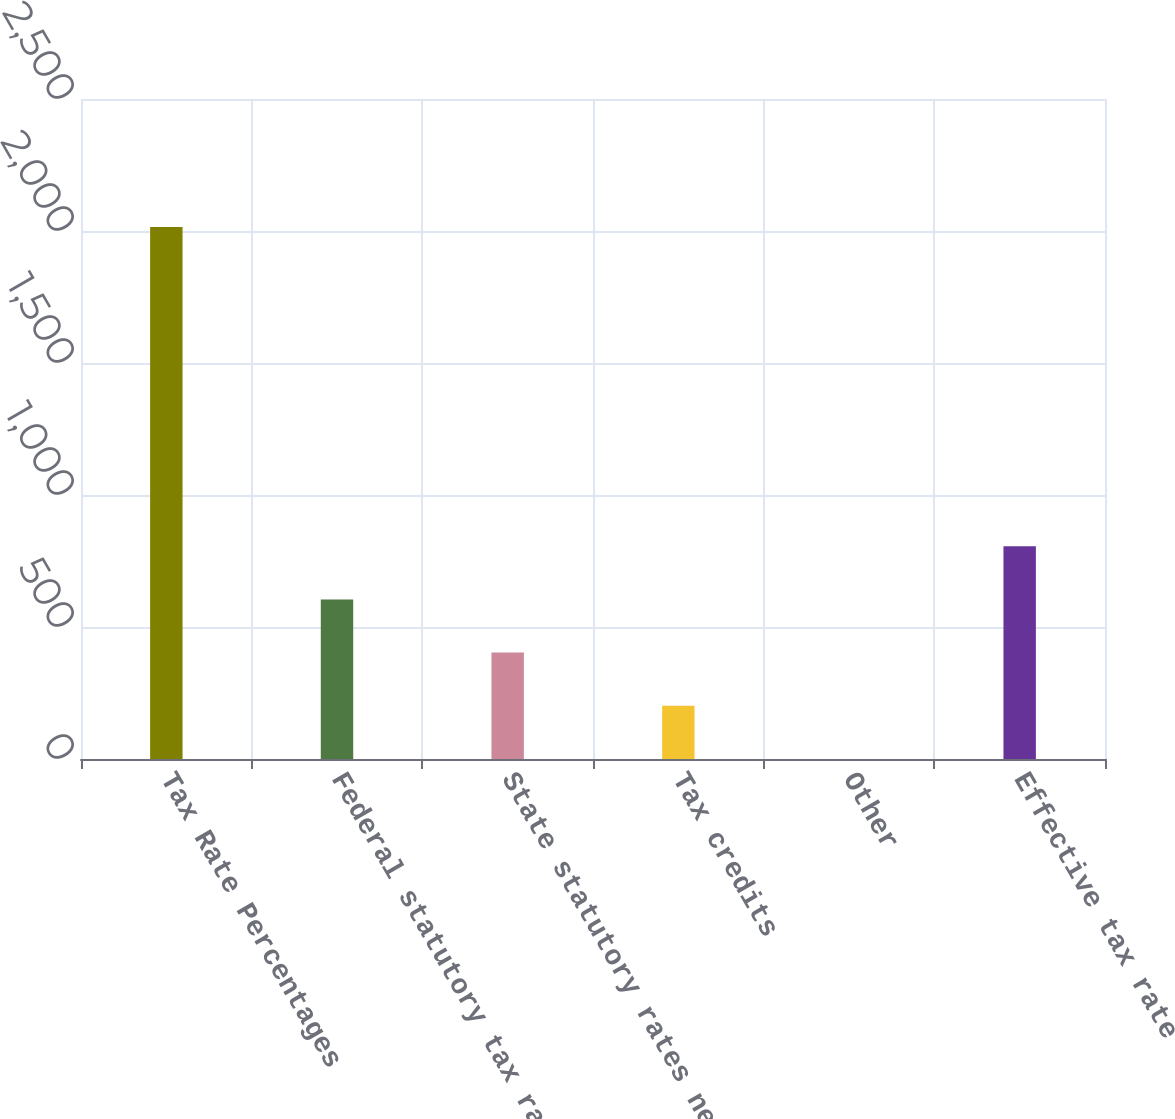Convert chart to OTSL. <chart><loc_0><loc_0><loc_500><loc_500><bar_chart><fcel>Tax Rate Percentages<fcel>Federal statutory tax rate<fcel>State statutory rates net of<fcel>Tax credits<fcel>Other<fcel>Effective tax rate<nl><fcel>2015<fcel>604.57<fcel>403.08<fcel>201.59<fcel>0.1<fcel>806.06<nl></chart> 